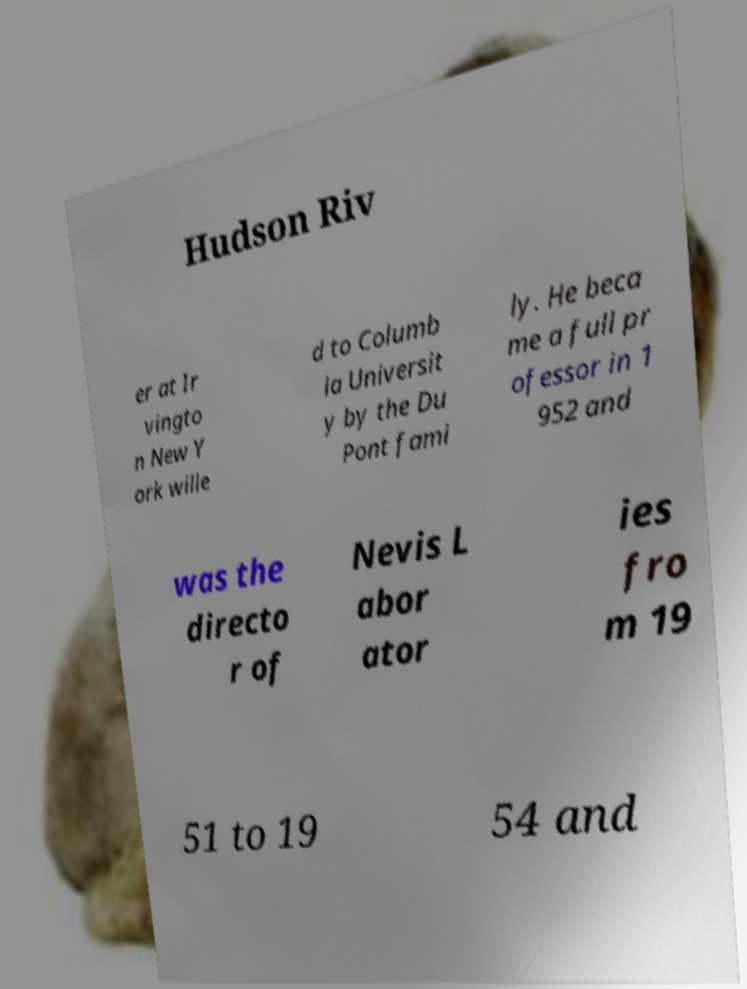Could you assist in decoding the text presented in this image and type it out clearly? Hudson Riv er at Ir vingto n New Y ork wille d to Columb ia Universit y by the Du Pont fami ly. He beca me a full pr ofessor in 1 952 and was the directo r of Nevis L abor ator ies fro m 19 51 to 19 54 and 